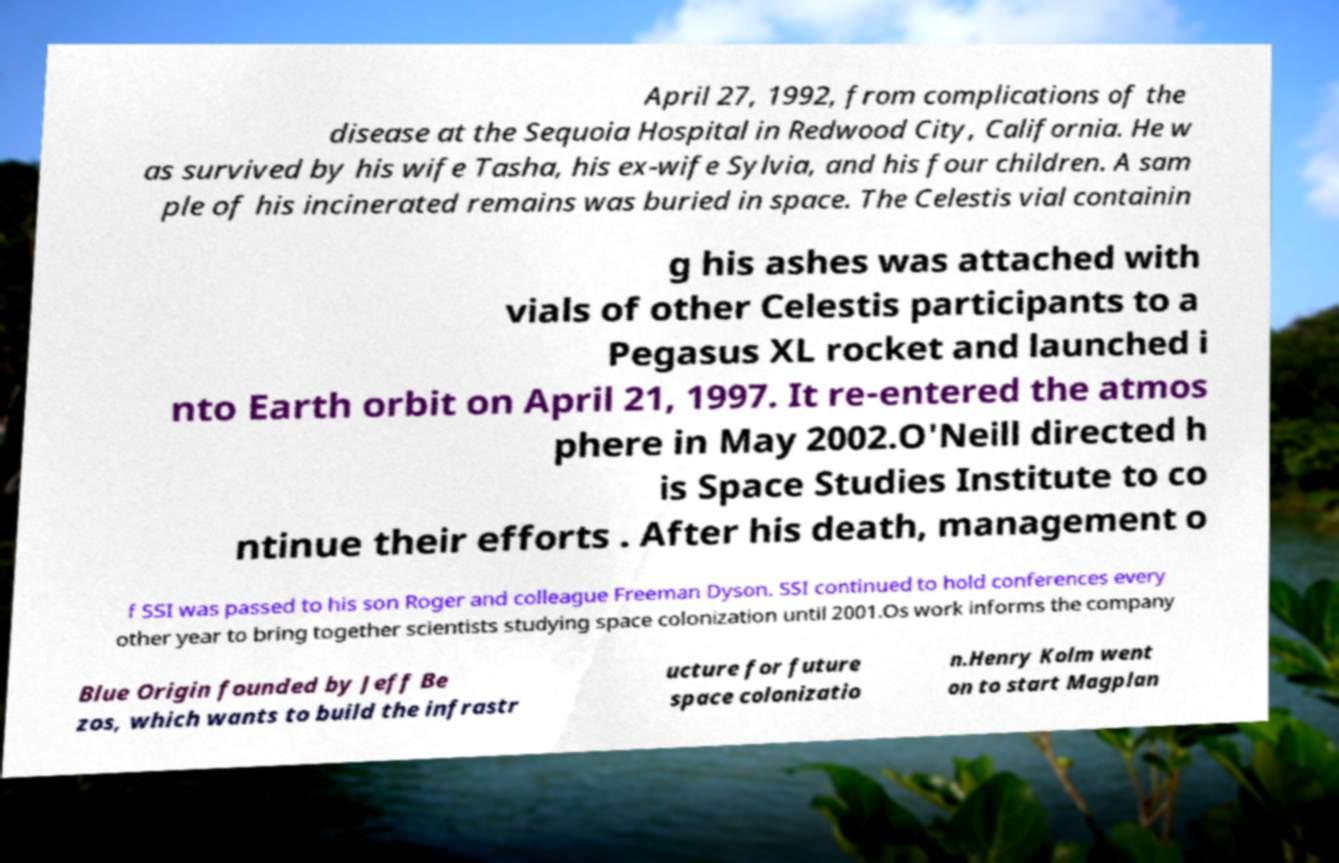Can you accurately transcribe the text from the provided image for me? April 27, 1992, from complications of the disease at the Sequoia Hospital in Redwood City, California. He w as survived by his wife Tasha, his ex-wife Sylvia, and his four children. A sam ple of his incinerated remains was buried in space. The Celestis vial containin g his ashes was attached with vials of other Celestis participants to a Pegasus XL rocket and launched i nto Earth orbit on April 21, 1997. It re-entered the atmos phere in May 2002.O'Neill directed h is Space Studies Institute to co ntinue their efforts . After his death, management o f SSI was passed to his son Roger and colleague Freeman Dyson. SSI continued to hold conferences every other year to bring together scientists studying space colonization until 2001.Os work informs the company Blue Origin founded by Jeff Be zos, which wants to build the infrastr ucture for future space colonizatio n.Henry Kolm went on to start Magplan 